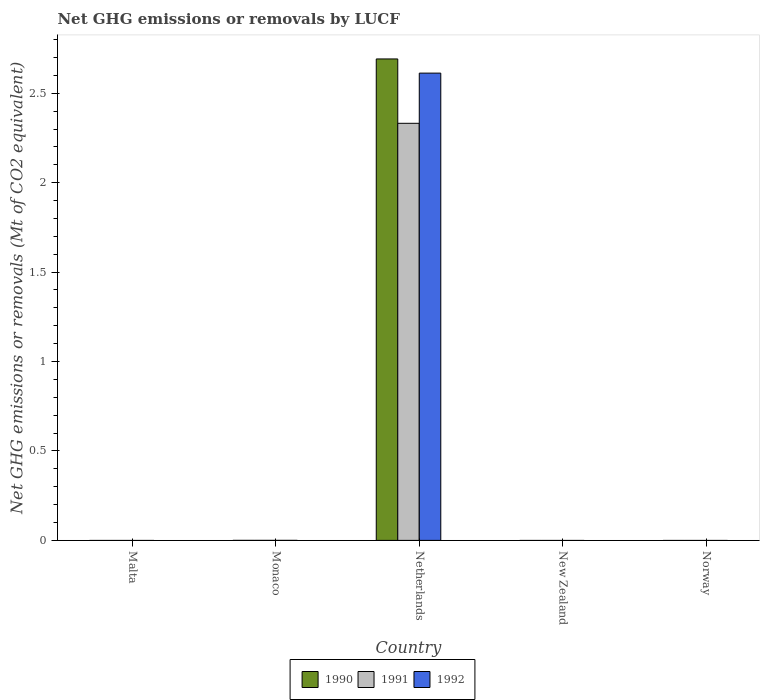How many different coloured bars are there?
Offer a terse response. 3. How many bars are there on the 1st tick from the left?
Give a very brief answer. 0. How many bars are there on the 1st tick from the right?
Your answer should be very brief. 0. What is the label of the 1st group of bars from the left?
Ensure brevity in your answer.  Malta. In how many cases, is the number of bars for a given country not equal to the number of legend labels?
Your answer should be very brief. 4. Across all countries, what is the maximum net GHG emissions or removals by LUCF in 1990?
Provide a short and direct response. 2.69. Across all countries, what is the minimum net GHG emissions or removals by LUCF in 1991?
Your answer should be compact. 0. In which country was the net GHG emissions or removals by LUCF in 1992 maximum?
Give a very brief answer. Netherlands. What is the total net GHG emissions or removals by LUCF in 1991 in the graph?
Your response must be concise. 2.33. What is the average net GHG emissions or removals by LUCF in 1991 per country?
Keep it short and to the point. 0.47. In how many countries, is the net GHG emissions or removals by LUCF in 1990 greater than 1.2 Mt?
Provide a short and direct response. 1. What is the difference between the highest and the lowest net GHG emissions or removals by LUCF in 1990?
Offer a terse response. 2.69. Is it the case that in every country, the sum of the net GHG emissions or removals by LUCF in 1990 and net GHG emissions or removals by LUCF in 1992 is greater than the net GHG emissions or removals by LUCF in 1991?
Give a very brief answer. No. How many bars are there?
Keep it short and to the point. 3. Are all the bars in the graph horizontal?
Your response must be concise. No. How many countries are there in the graph?
Your answer should be very brief. 5. What is the difference between two consecutive major ticks on the Y-axis?
Keep it short and to the point. 0.5. Are the values on the major ticks of Y-axis written in scientific E-notation?
Provide a short and direct response. No. Does the graph contain grids?
Your answer should be very brief. No. Where does the legend appear in the graph?
Provide a succinct answer. Bottom center. What is the title of the graph?
Provide a succinct answer. Net GHG emissions or removals by LUCF. Does "1982" appear as one of the legend labels in the graph?
Keep it short and to the point. No. What is the label or title of the X-axis?
Offer a very short reply. Country. What is the label or title of the Y-axis?
Provide a short and direct response. Net GHG emissions or removals (Mt of CO2 equivalent). What is the Net GHG emissions or removals (Mt of CO2 equivalent) in 1992 in Malta?
Your answer should be compact. 0. What is the Net GHG emissions or removals (Mt of CO2 equivalent) in 1990 in Monaco?
Your response must be concise. 0. What is the Net GHG emissions or removals (Mt of CO2 equivalent) in 1992 in Monaco?
Provide a succinct answer. 0. What is the Net GHG emissions or removals (Mt of CO2 equivalent) in 1990 in Netherlands?
Keep it short and to the point. 2.69. What is the Net GHG emissions or removals (Mt of CO2 equivalent) in 1991 in Netherlands?
Give a very brief answer. 2.33. What is the Net GHG emissions or removals (Mt of CO2 equivalent) of 1992 in Netherlands?
Offer a terse response. 2.61. What is the Net GHG emissions or removals (Mt of CO2 equivalent) in 1990 in New Zealand?
Ensure brevity in your answer.  0. What is the Net GHG emissions or removals (Mt of CO2 equivalent) in 1990 in Norway?
Your answer should be very brief. 0. What is the Net GHG emissions or removals (Mt of CO2 equivalent) of 1992 in Norway?
Your answer should be very brief. 0. Across all countries, what is the maximum Net GHG emissions or removals (Mt of CO2 equivalent) of 1990?
Provide a short and direct response. 2.69. Across all countries, what is the maximum Net GHG emissions or removals (Mt of CO2 equivalent) in 1991?
Make the answer very short. 2.33. Across all countries, what is the maximum Net GHG emissions or removals (Mt of CO2 equivalent) of 1992?
Provide a succinct answer. 2.61. Across all countries, what is the minimum Net GHG emissions or removals (Mt of CO2 equivalent) of 1990?
Offer a very short reply. 0. Across all countries, what is the minimum Net GHG emissions or removals (Mt of CO2 equivalent) in 1991?
Offer a terse response. 0. Across all countries, what is the minimum Net GHG emissions or removals (Mt of CO2 equivalent) of 1992?
Offer a terse response. 0. What is the total Net GHG emissions or removals (Mt of CO2 equivalent) in 1990 in the graph?
Your answer should be compact. 2.69. What is the total Net GHG emissions or removals (Mt of CO2 equivalent) of 1991 in the graph?
Offer a very short reply. 2.33. What is the total Net GHG emissions or removals (Mt of CO2 equivalent) in 1992 in the graph?
Provide a succinct answer. 2.61. What is the average Net GHG emissions or removals (Mt of CO2 equivalent) in 1990 per country?
Keep it short and to the point. 0.54. What is the average Net GHG emissions or removals (Mt of CO2 equivalent) of 1991 per country?
Offer a terse response. 0.47. What is the average Net GHG emissions or removals (Mt of CO2 equivalent) in 1992 per country?
Your answer should be very brief. 0.52. What is the difference between the Net GHG emissions or removals (Mt of CO2 equivalent) in 1990 and Net GHG emissions or removals (Mt of CO2 equivalent) in 1991 in Netherlands?
Keep it short and to the point. 0.36. What is the difference between the Net GHG emissions or removals (Mt of CO2 equivalent) of 1990 and Net GHG emissions or removals (Mt of CO2 equivalent) of 1992 in Netherlands?
Your response must be concise. 0.08. What is the difference between the Net GHG emissions or removals (Mt of CO2 equivalent) of 1991 and Net GHG emissions or removals (Mt of CO2 equivalent) of 1992 in Netherlands?
Ensure brevity in your answer.  -0.28. What is the difference between the highest and the lowest Net GHG emissions or removals (Mt of CO2 equivalent) in 1990?
Provide a short and direct response. 2.69. What is the difference between the highest and the lowest Net GHG emissions or removals (Mt of CO2 equivalent) of 1991?
Your answer should be compact. 2.33. What is the difference between the highest and the lowest Net GHG emissions or removals (Mt of CO2 equivalent) in 1992?
Provide a short and direct response. 2.61. 